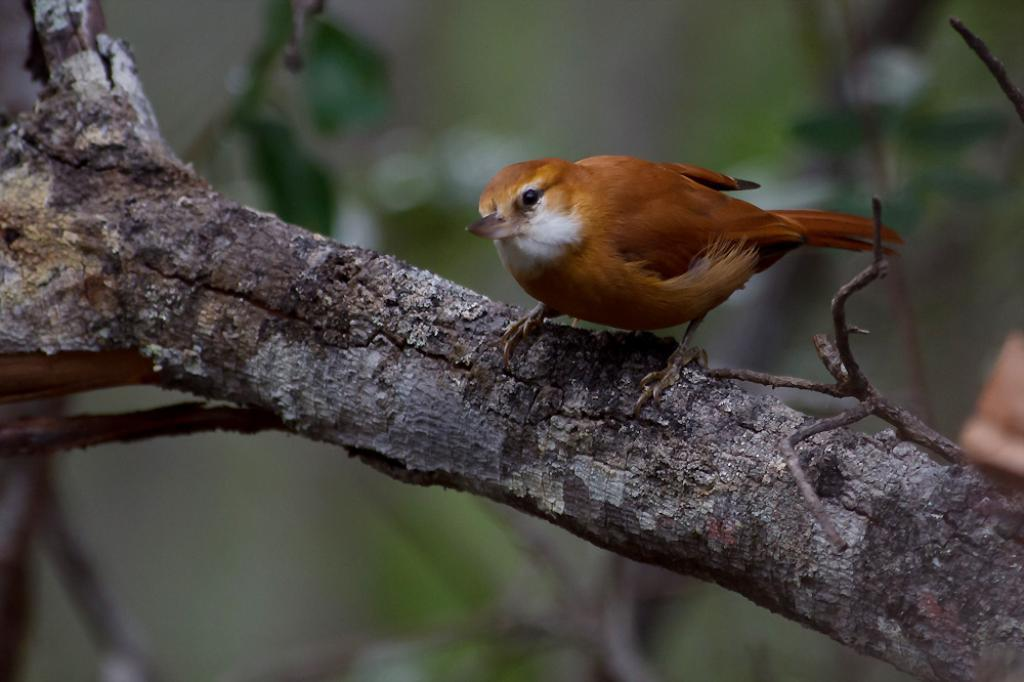What type of animal is in the image? There is a brown bird in the image. Where is the bird located? The bird is on a wooden branch. What type of corn is being used for teaching in the image? There is no corn or teaching activity present in the image; it features a brown bird on a wooden branch. 